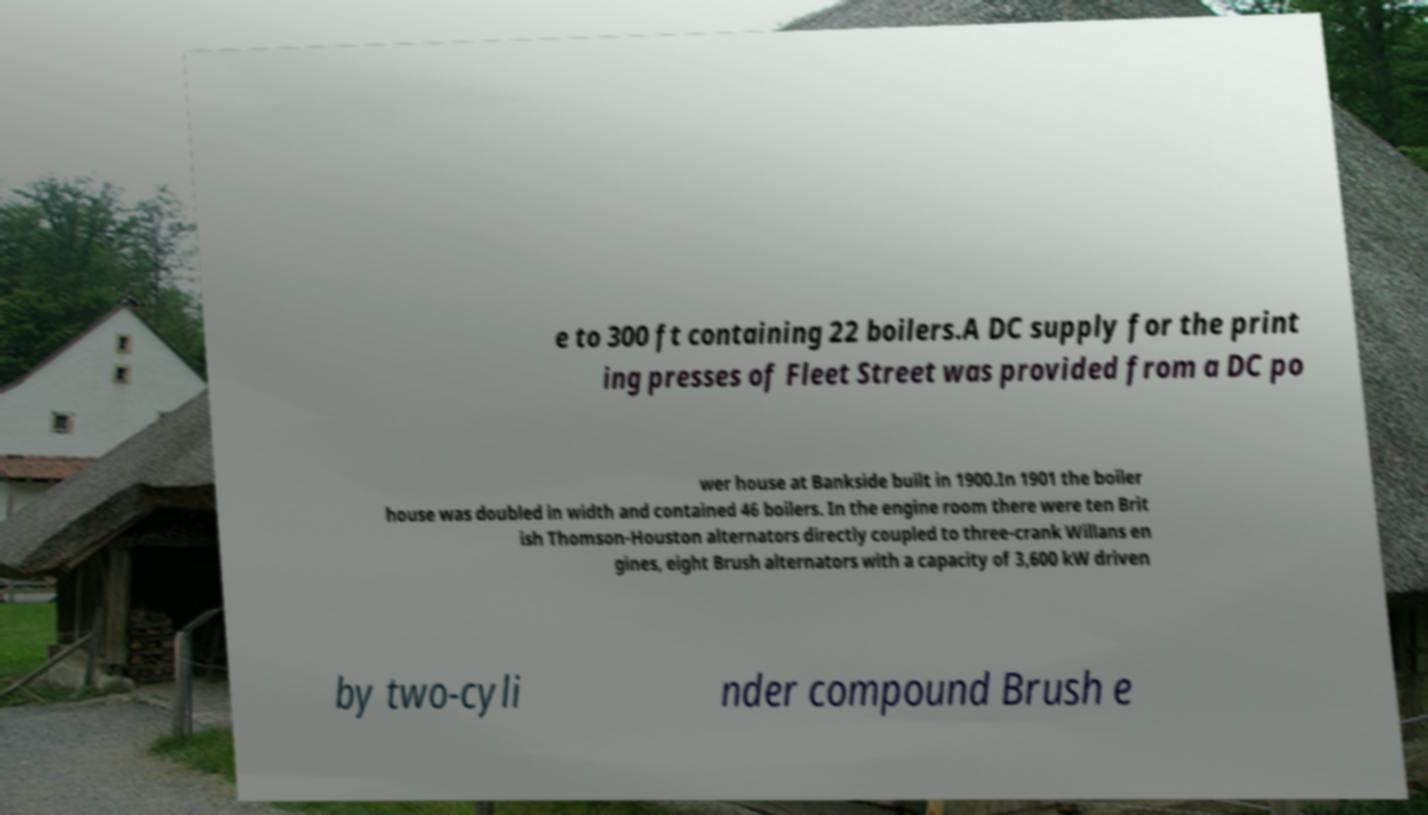There's text embedded in this image that I need extracted. Can you transcribe it verbatim? e to 300 ft containing 22 boilers.A DC supply for the print ing presses of Fleet Street was provided from a DC po wer house at Bankside built in 1900.In 1901 the boiler house was doubled in width and contained 46 boilers. In the engine room there were ten Brit ish Thomson-Houston alternators directly coupled to three-crank Willans en gines, eight Brush alternators with a capacity of 3,600 kW driven by two-cyli nder compound Brush e 